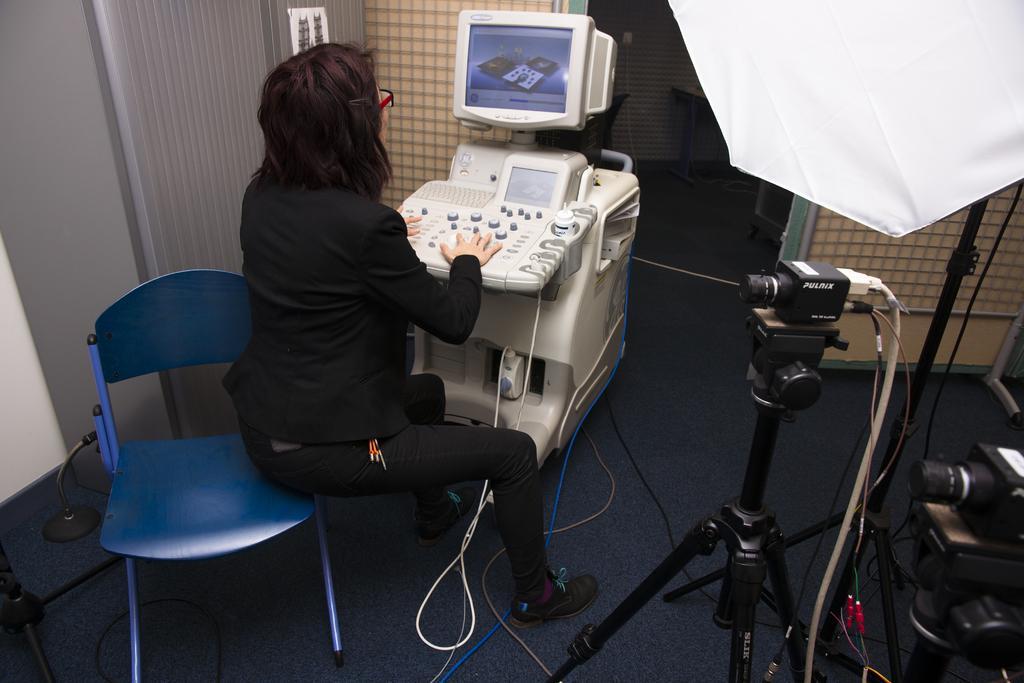Could you give a brief overview of what you see in this image? This image consists of a chair, which is in blue color and a person in the middle who is in black dress. An equipment is in front of her. There is a monitor on the top. On the right side bottom corner there are camera stands and an umbrella like thing is present in the top bottom, top right corner. 